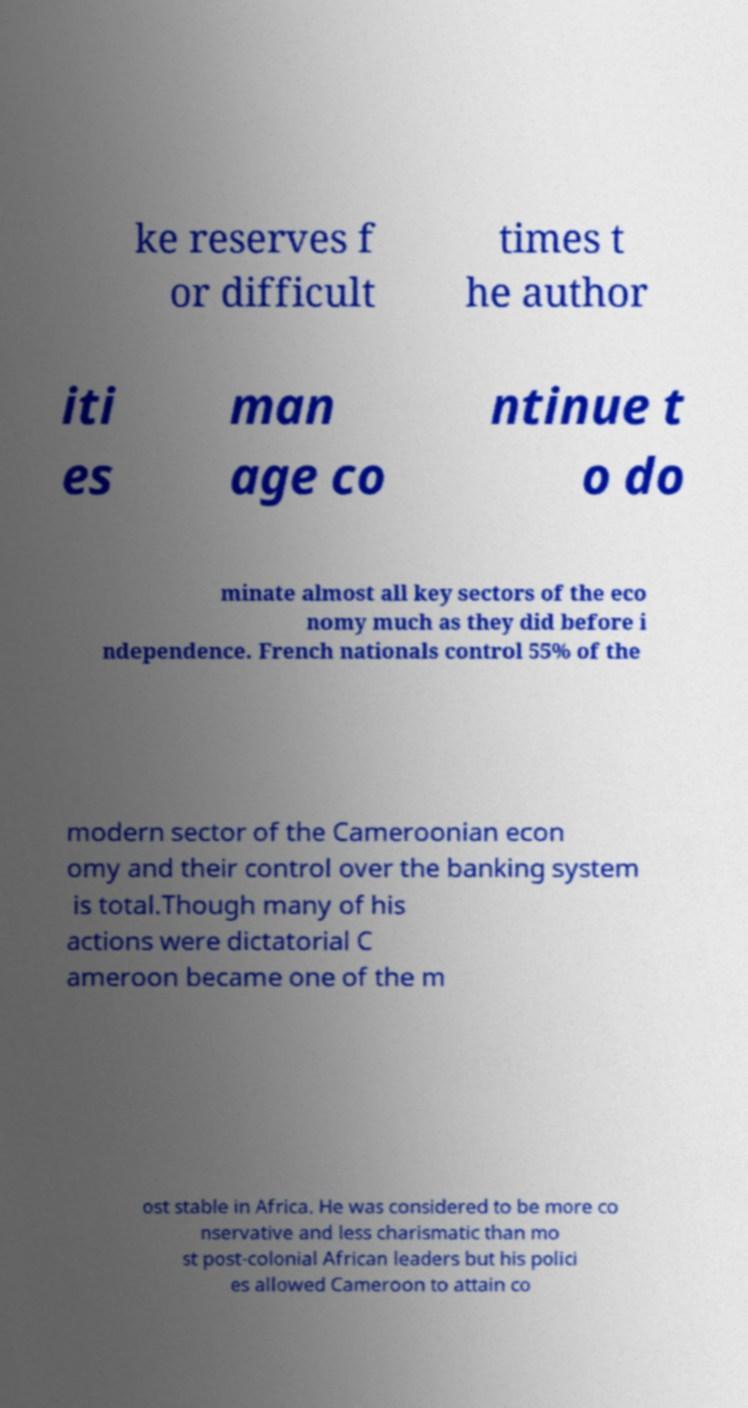For documentation purposes, I need the text within this image transcribed. Could you provide that? ke reserves f or difficult times t he author iti es man age co ntinue t o do minate almost all key sectors of the eco nomy much as they did before i ndependence. French nationals control 55% of the modern sector of the Cameroonian econ omy and their control over the banking system is total.Though many of his actions were dictatorial C ameroon became one of the m ost stable in Africa. He was considered to be more co nservative and less charismatic than mo st post-colonial African leaders but his polici es allowed Cameroon to attain co 